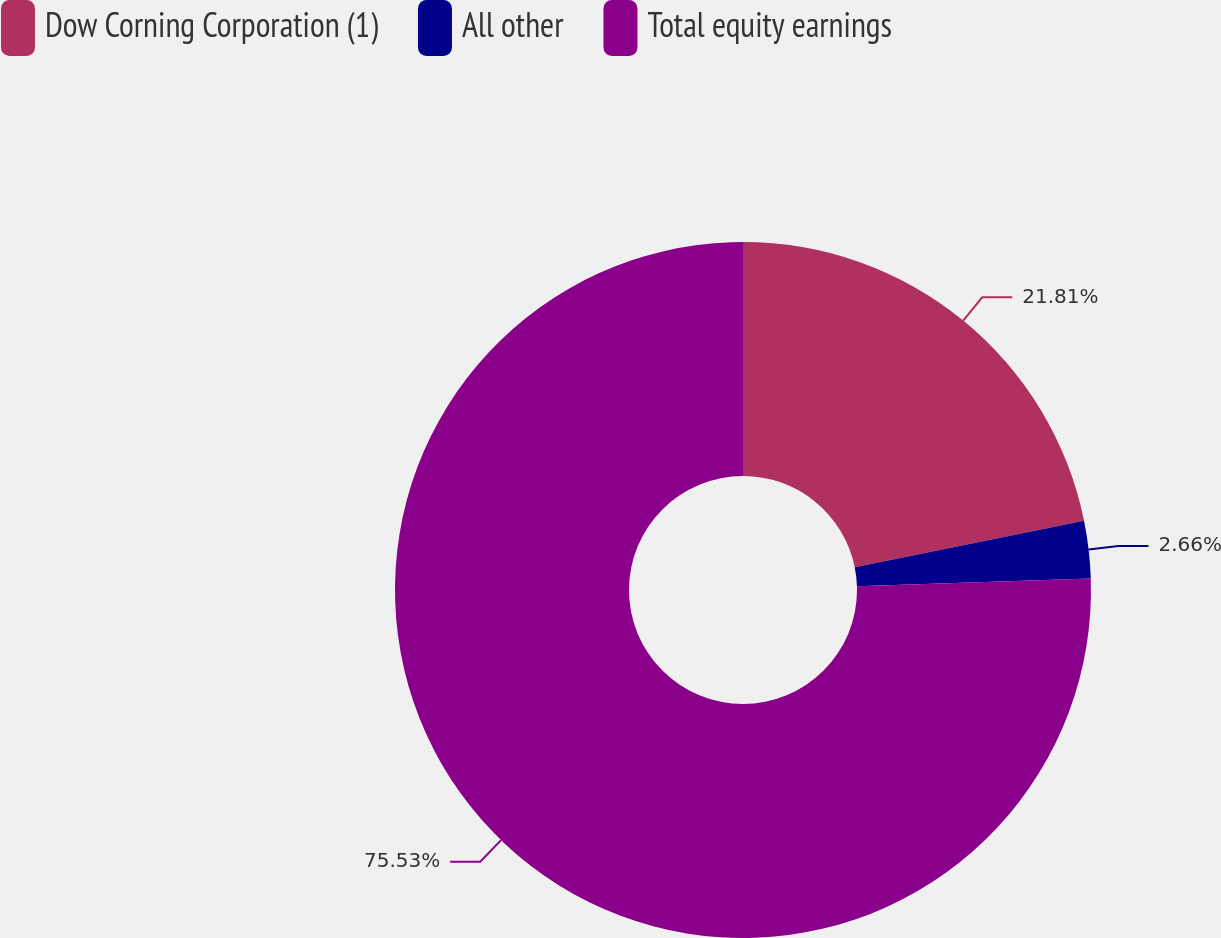Convert chart to OTSL. <chart><loc_0><loc_0><loc_500><loc_500><pie_chart><fcel>Dow Corning Corporation (1)<fcel>All other<fcel>Total equity earnings<nl><fcel>21.81%<fcel>2.66%<fcel>75.53%<nl></chart> 